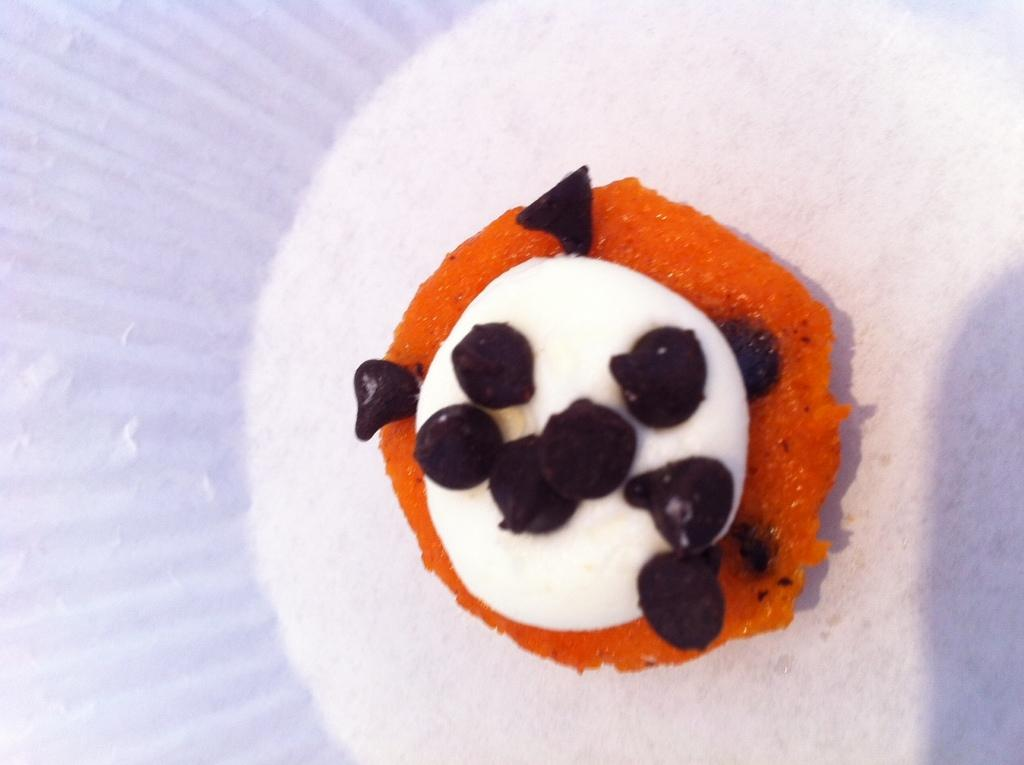What is the main subject of the image? There is a food item in the image. What type of grain is being squeezed to make the juice in the image? There is no juice or grain present in the image; it only features a food item. 